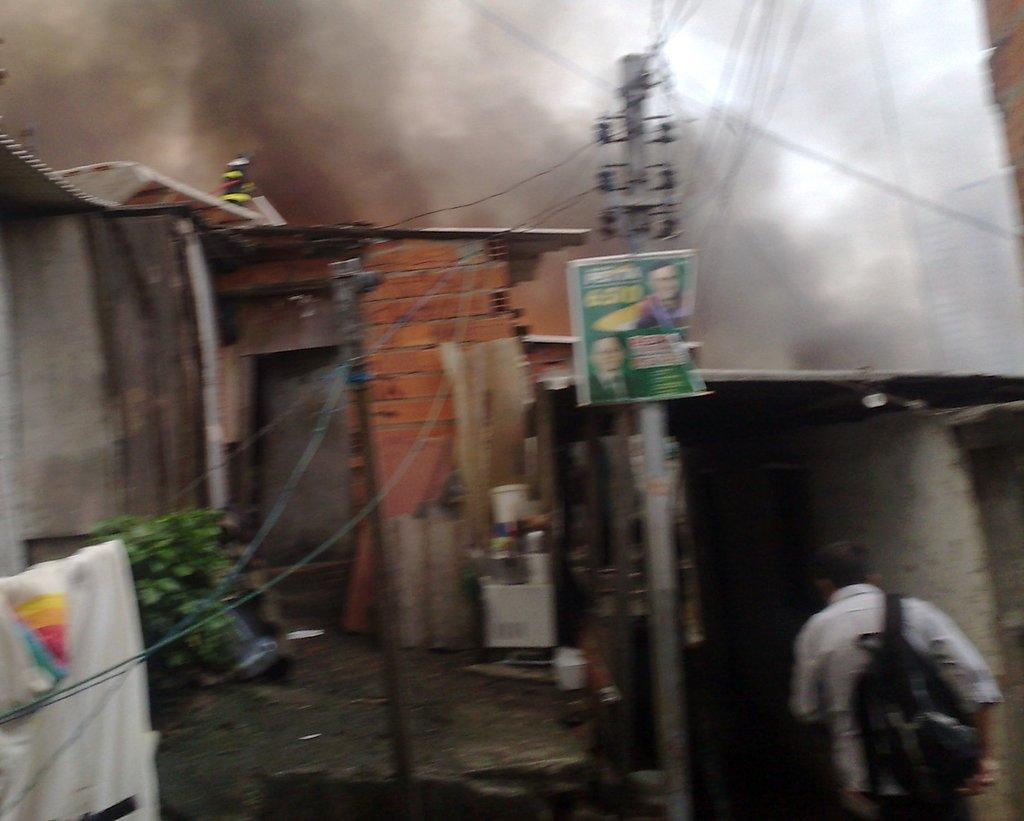What structure can be seen in the image? There is an electric pole in the image. What is connected to the electric pole? There are wires in the image. What type of buildings are visible in the image? There are houses in the image. What is the person in the image doing? There is a person on the road in the image. What can be seen at the top of the image? Smoke is visible at the top of the image. What time of day might the image have been taken? The image may have been taken in the evening, as indicated by the presence of smoke. What type of vein is visible in the image? There is no vein present in the image; it features an electric pole, wires, houses, a person on the road, and smoke. How many birds can be seen flying in the image? There are no birds visible in the image. 